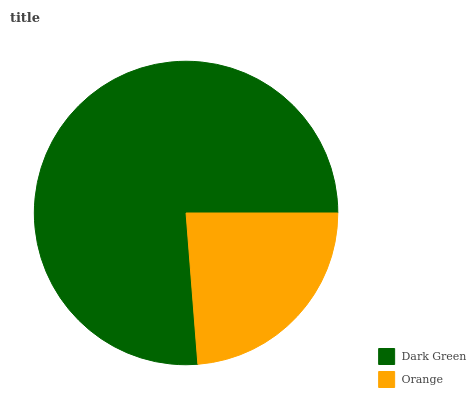Is Orange the minimum?
Answer yes or no. Yes. Is Dark Green the maximum?
Answer yes or no. Yes. Is Orange the maximum?
Answer yes or no. No. Is Dark Green greater than Orange?
Answer yes or no. Yes. Is Orange less than Dark Green?
Answer yes or no. Yes. Is Orange greater than Dark Green?
Answer yes or no. No. Is Dark Green less than Orange?
Answer yes or no. No. Is Dark Green the high median?
Answer yes or no. Yes. Is Orange the low median?
Answer yes or no. Yes. Is Orange the high median?
Answer yes or no. No. Is Dark Green the low median?
Answer yes or no. No. 